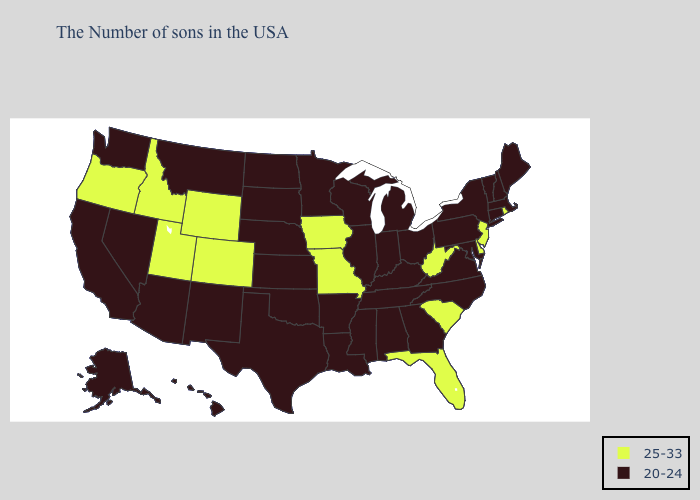Among the states that border New Jersey , which have the highest value?
Write a very short answer. Delaware. Name the states that have a value in the range 25-33?
Keep it brief. Rhode Island, New Jersey, Delaware, South Carolina, West Virginia, Florida, Missouri, Iowa, Wyoming, Colorado, Utah, Idaho, Oregon. Does the map have missing data?
Write a very short answer. No. What is the highest value in the Northeast ?
Write a very short answer. 25-33. What is the lowest value in the West?
Short answer required. 20-24. Which states have the lowest value in the USA?
Short answer required. Maine, Massachusetts, New Hampshire, Vermont, Connecticut, New York, Maryland, Pennsylvania, Virginia, North Carolina, Ohio, Georgia, Michigan, Kentucky, Indiana, Alabama, Tennessee, Wisconsin, Illinois, Mississippi, Louisiana, Arkansas, Minnesota, Kansas, Nebraska, Oklahoma, Texas, South Dakota, North Dakota, New Mexico, Montana, Arizona, Nevada, California, Washington, Alaska, Hawaii. What is the highest value in states that border Minnesota?
Write a very short answer. 25-33. What is the lowest value in the USA?
Quick response, please. 20-24. Does the map have missing data?
Short answer required. No. Does Florida have the same value as Delaware?
Answer briefly. Yes. Name the states that have a value in the range 25-33?
Give a very brief answer. Rhode Island, New Jersey, Delaware, South Carolina, West Virginia, Florida, Missouri, Iowa, Wyoming, Colorado, Utah, Idaho, Oregon. What is the value of Wisconsin?
Keep it brief. 20-24. Does Rhode Island have the same value as Washington?
Be succinct. No. Does the first symbol in the legend represent the smallest category?
Quick response, please. No. What is the value of Arkansas?
Write a very short answer. 20-24. 